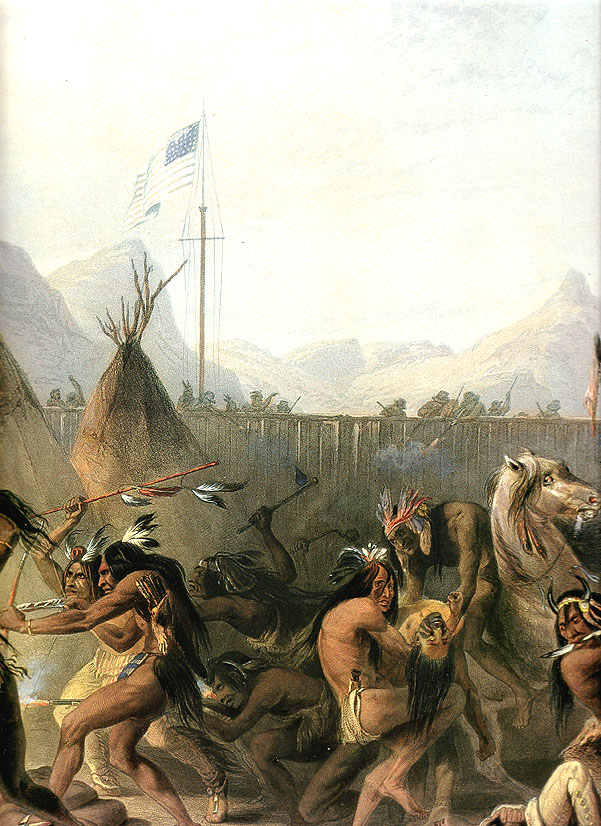Can you describe the attire of the individuals in this painting? The individuals in the painting are wearing traditional Native American attire, which includes breechcloths, leggings, and intricate feathered headdresses. Some appear to have their bodies painted, possibly for ceremonial purposes. Each piece of attire is rich in color and detail, indicative of their cultural significance and personal identities within the tribe. 